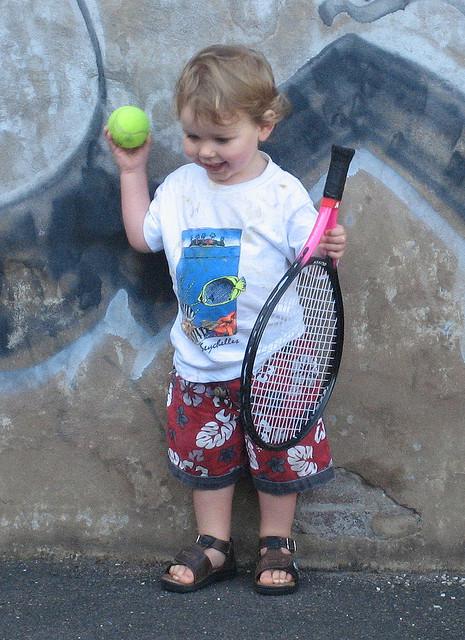Is the kid holding a ball?
Answer briefly. Yes. How many fish are on the kids shirt?
Be succinct. 2. What kind of shoes is the boy wearing?
Be succinct. Sandals. 